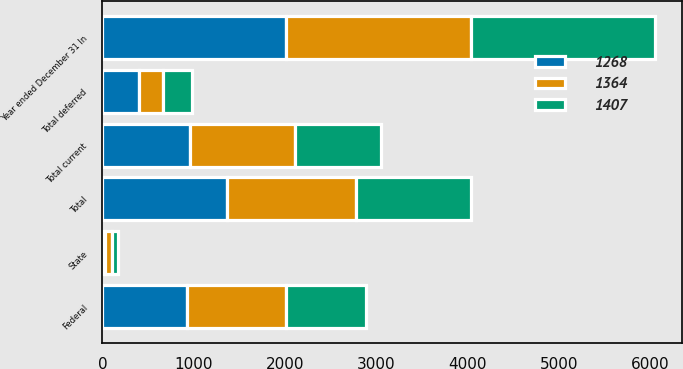Convert chart to OTSL. <chart><loc_0><loc_0><loc_500><loc_500><stacked_bar_chart><ecel><fcel>Year ended December 31 In<fcel>Federal<fcel>State<fcel>Total current<fcel>Total deferred<fcel>Total<nl><fcel>1407<fcel>2016<fcel>871<fcel>71<fcel>942<fcel>326<fcel>1268<nl><fcel>1268<fcel>2015<fcel>927<fcel>33<fcel>960<fcel>404<fcel>1364<nl><fcel>1364<fcel>2014<fcel>1084<fcel>68<fcel>1152<fcel>255<fcel>1407<nl></chart> 